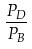<formula> <loc_0><loc_0><loc_500><loc_500>\frac { P _ { D } } { P _ { B } }</formula> 